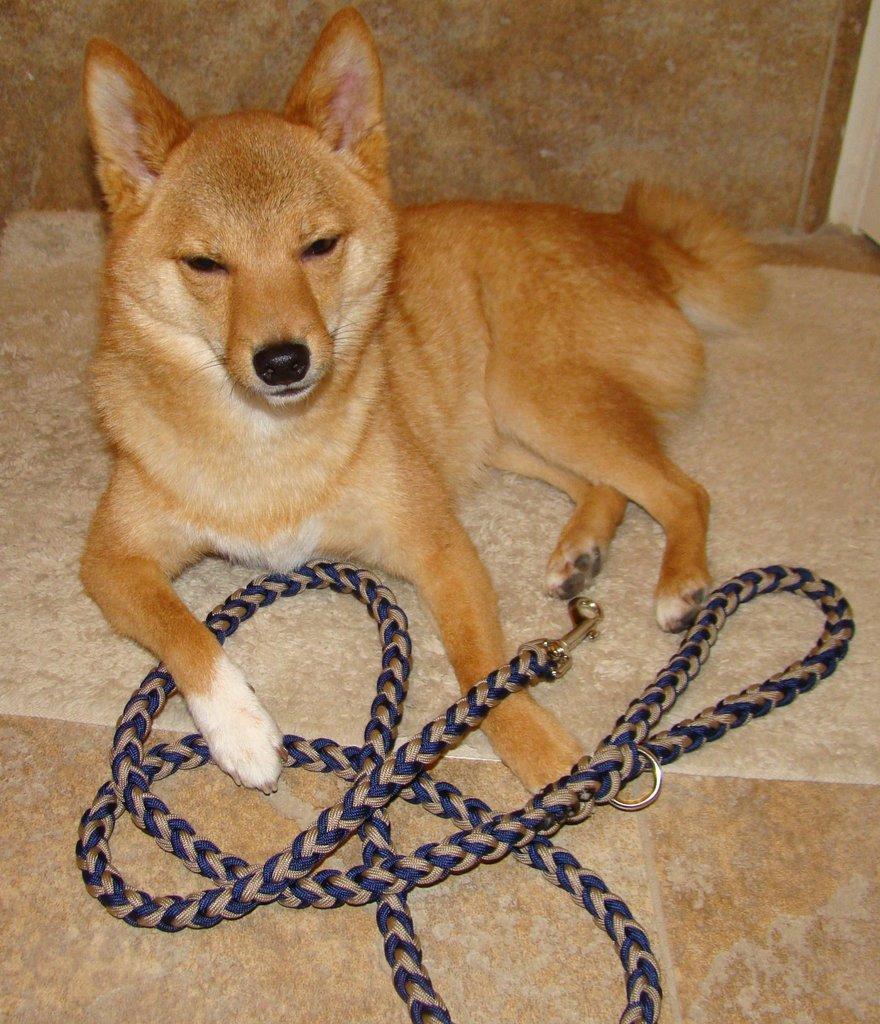Describe this image in one or two sentences. In front of the image there is a dog sitting on the mat. In front of the dog there is a rope. Behind the dog there is a wall. 